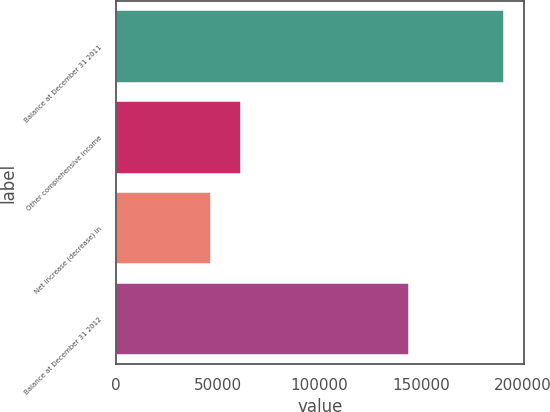<chart> <loc_0><loc_0><loc_500><loc_500><bar_chart><fcel>Balance at December 31 2011<fcel>Other comprehensive income<fcel>Net increase (decrease) in<fcel>Balance at December 31 2012<nl><fcel>190970<fcel>61190<fcel>46770<fcel>144200<nl></chart> 